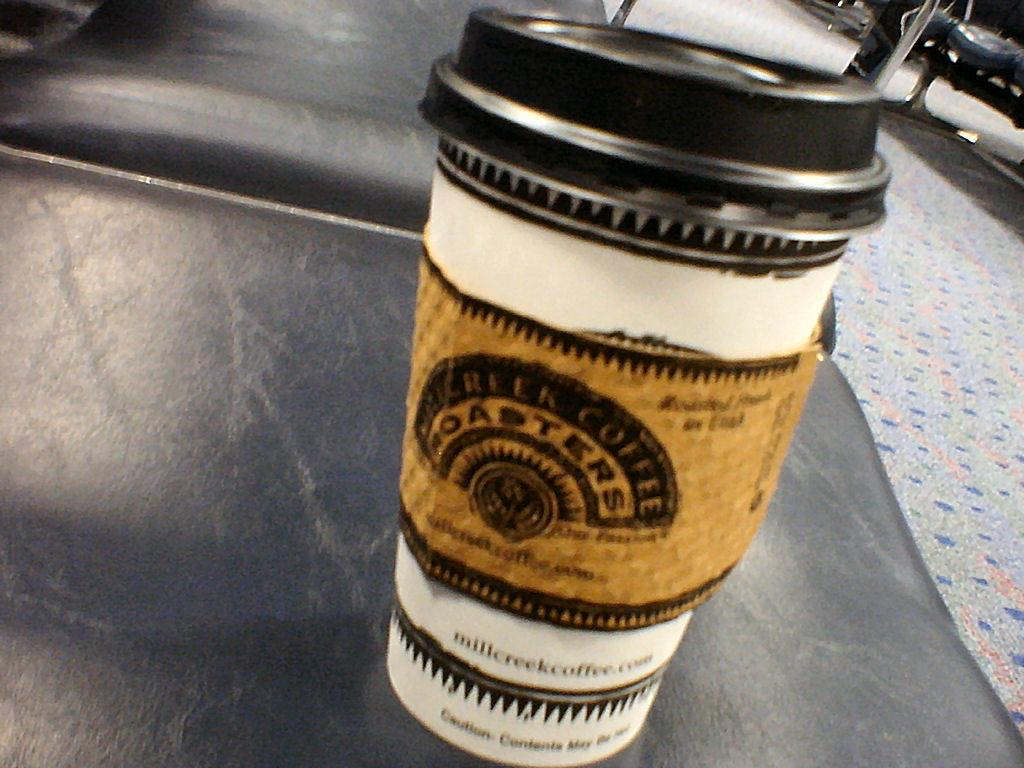Provide a one-sentence caption for the provided image. The coffee cup Coasters has a nice looking logo and design. 